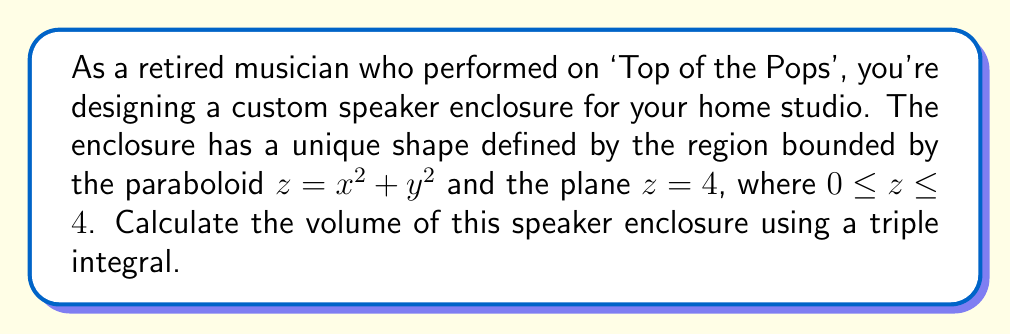Could you help me with this problem? Let's approach this step-by-step:

1) The volume we need to calculate is bounded by $z = x^2 + y^2$ from below and $z = 4$ from above.

2) We'll use cylindrical coordinates for this problem. The transformation is:
   $x = r \cos\theta$
   $y = r \sin\theta$
   $z = z$

3) In cylindrical coordinates, the equation $z = x^2 + y^2$ becomes $z = r^2$.

4) The limits of integration will be:
   $0 \leq z \leq 4$
   $0 \leq \theta \leq 2\pi$
   $0 \leq r \leq 2$ (because when $z = 4$, $r^2 = 4$, so $r = 2$)

5) The volume integral in cylindrical coordinates is:

   $$V = \int_0^{2\pi} \int_0^2 \int_{r^2}^4 r \, dz \, dr \, d\theta$$

6) Let's solve the inner integral first:

   $$\int_{r^2}^4 r \, dz = r[z]_{r^2}^4 = 4r - r^3$$

7) Now our integral is:

   $$V = \int_0^{2\pi} \int_0^2 (4r - r^3) \, dr \, d\theta$$

8) Solving the $r$ integral:

   $$\int_0^2 (4r - r^3) \, dr = [2r^2 - \frac{1}{4}r^4]_0^2 = 8 - 4 = 4$$

9) Our final integral is:

   $$V = \int_0^{2\pi} 4 \, d\theta = 4[{\theta}]_0^{2\pi} = 8\pi$$

Therefore, the volume of the speaker enclosure is $8\pi$ cubic units.
Answer: $8\pi$ cubic units 